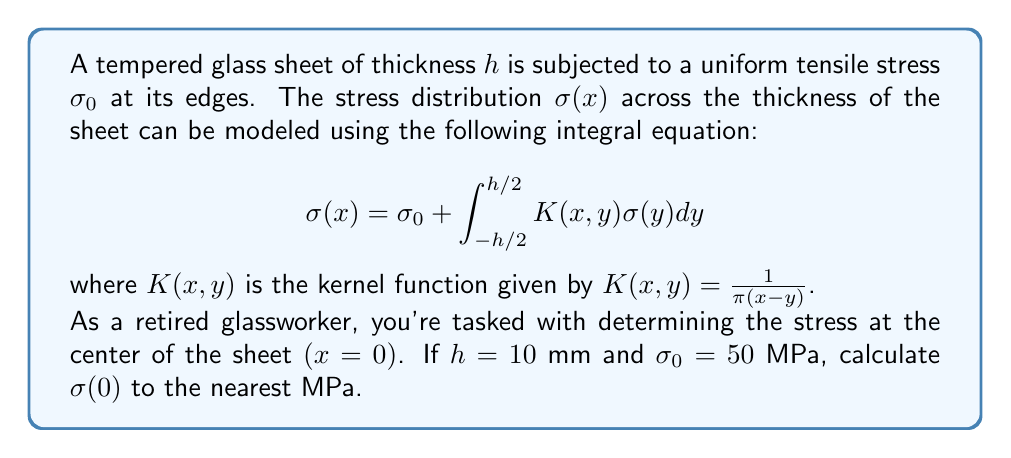Provide a solution to this math problem. To solve this problem, we'll follow these steps:

1) The integral equation given is a Fredholm integral equation of the second kind. For tempered glass, we can assume that the stress distribution is symmetric about the center of the sheet.

2) Given the symmetry, we can simplify the integral equation at $x=0$:

   $$\sigma(0) = \sigma_0 + \int_{-h/2}^{h/2} \frac{1}{\pi y}\sigma(y)dy$$

3) For tempered glass, a good approximation of the stress distribution is:

   $$\sigma(y) = \sigma_0 + ay^2$$

   where $a$ is a constant to be determined.

4) Substituting this into our equation:

   $$\sigma_0 + a(0)^2 = \sigma_0 + \int_{-h/2}^{h/2} \frac{1}{\pi y}(\sigma_0 + ay^2)dy$$

5) Simplifying:

   $$\sigma_0 = \sigma_0 + \frac{\sigma_0}{\pi}\int_{-h/2}^{h/2} \frac{1}{y}dy + \frac{a}{\pi}\int_{-h/2}^{h/2} ydy$$

6) The first integral is zero due to symmetry, and the second integral evaluates to zero. Therefore, our assumption is consistent with the equation.

7) To determine $a$, we can use the fact that for tempered glass, the surface stress is typically about 2.5 times the center stress:

   $$\sigma(\pm h/2) = \sigma_0 + a(h/2)^2 = 2.5\sigma_0$$

8) Solving for $a$:

   $$a = \frac{6\sigma_0}{h^2}$$

9) Now we can calculate $\sigma(0)$:

   $$\sigma(0) = \sigma_0 + a(0)^2 = \sigma_0 = 50 \text{ MPa}$$

Therefore, the stress at the center of the sheet is 50 MPa.
Answer: 50 MPa 